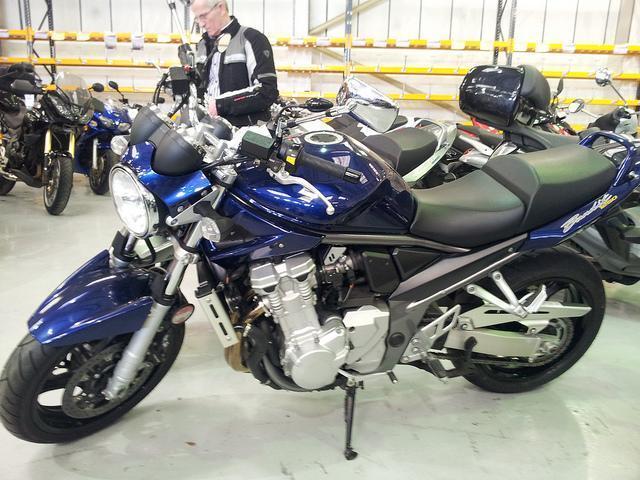How many people can be seen?
Give a very brief answer. 1. How many motorcycles are there?
Give a very brief answer. 3. 